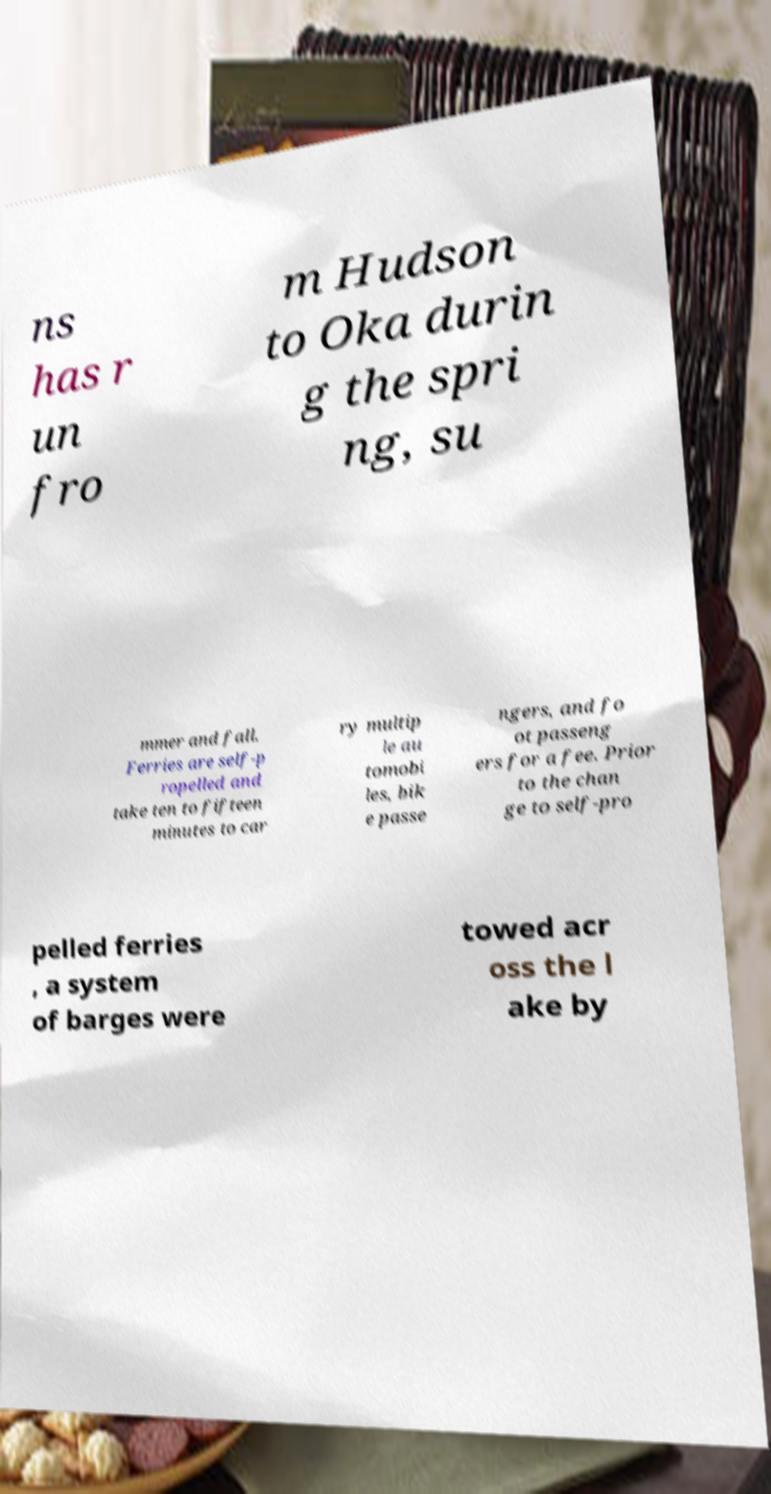I need the written content from this picture converted into text. Can you do that? ns has r un fro m Hudson to Oka durin g the spri ng, su mmer and fall. Ferries are self-p ropelled and take ten to fifteen minutes to car ry multip le au tomobi les, bik e passe ngers, and fo ot passeng ers for a fee. Prior to the chan ge to self-pro pelled ferries , a system of barges were towed acr oss the l ake by 